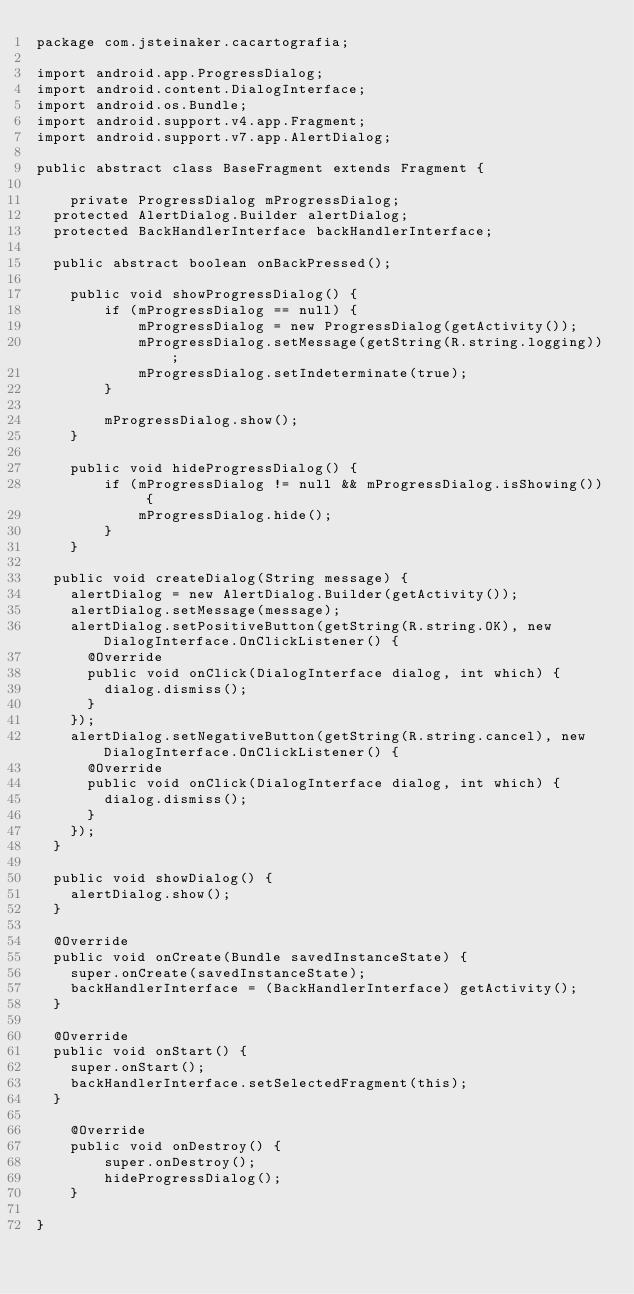<code> <loc_0><loc_0><loc_500><loc_500><_Java_>package com.jsteinaker.cacartografia;

import android.app.ProgressDialog;
import android.content.DialogInterface;
import android.os.Bundle;
import android.support.v4.app.Fragment;
import android.support.v7.app.AlertDialog;

public abstract class BaseFragment extends Fragment {

    private ProgressDialog mProgressDialog;
	protected AlertDialog.Builder alertDialog;
	protected BackHandlerInterface backHandlerInterface;
	
	public abstract boolean onBackPressed();

    public void showProgressDialog() {
        if (mProgressDialog == null) {
            mProgressDialog = new ProgressDialog(getActivity());
            mProgressDialog.setMessage(getString(R.string.logging));
            mProgressDialog.setIndeterminate(true);
        }

        mProgressDialog.show();
    }

    public void hideProgressDialog() {
        if (mProgressDialog != null && mProgressDialog.isShowing()) {
            mProgressDialog.hide();
        }
    }

	public void createDialog(String message) {
		alertDialog = new AlertDialog.Builder(getActivity());
		alertDialog.setMessage(message);
		alertDialog.setPositiveButton(getString(R.string.OK), new DialogInterface.OnClickListener() {
			@Override
			public void onClick(DialogInterface dialog, int which) {
				dialog.dismiss();
			}
		});
		alertDialog.setNegativeButton(getString(R.string.cancel), new  DialogInterface.OnClickListener() {
			@Override
			public void onClick(DialogInterface dialog, int which) {
				dialog.dismiss();
			}
		});
	}

	public void showDialog() {
		alertDialog.show();
	}

	@Override
	public void onCreate(Bundle savedInstanceState) {
		super.onCreate(savedInstanceState);
		backHandlerInterface = (BackHandlerInterface) getActivity();
	}

	@Override
	public void onStart() {
		super.onStart();
		backHandlerInterface.setSelectedFragment(this);
	}

    @Override
    public void onDestroy() {
        super.onDestroy();
        hideProgressDialog();
    }

}
</code> 